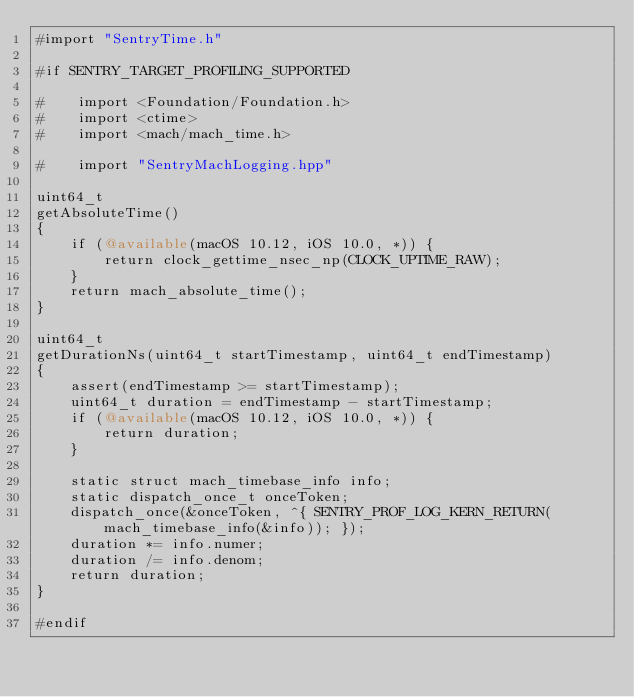<code> <loc_0><loc_0><loc_500><loc_500><_ObjectiveC_>#import "SentryTime.h"

#if SENTRY_TARGET_PROFILING_SUPPORTED

#    import <Foundation/Foundation.h>
#    import <ctime>
#    import <mach/mach_time.h>

#    import "SentryMachLogging.hpp"

uint64_t
getAbsoluteTime()
{
    if (@available(macOS 10.12, iOS 10.0, *)) {
        return clock_gettime_nsec_np(CLOCK_UPTIME_RAW);
    }
    return mach_absolute_time();
}

uint64_t
getDurationNs(uint64_t startTimestamp, uint64_t endTimestamp)
{
    assert(endTimestamp >= startTimestamp);
    uint64_t duration = endTimestamp - startTimestamp;
    if (@available(macOS 10.12, iOS 10.0, *)) {
        return duration;
    }

    static struct mach_timebase_info info;
    static dispatch_once_t onceToken;
    dispatch_once(&onceToken, ^{ SENTRY_PROF_LOG_KERN_RETURN(mach_timebase_info(&info)); });
    duration *= info.numer;
    duration /= info.denom;
    return duration;
}

#endif
</code> 